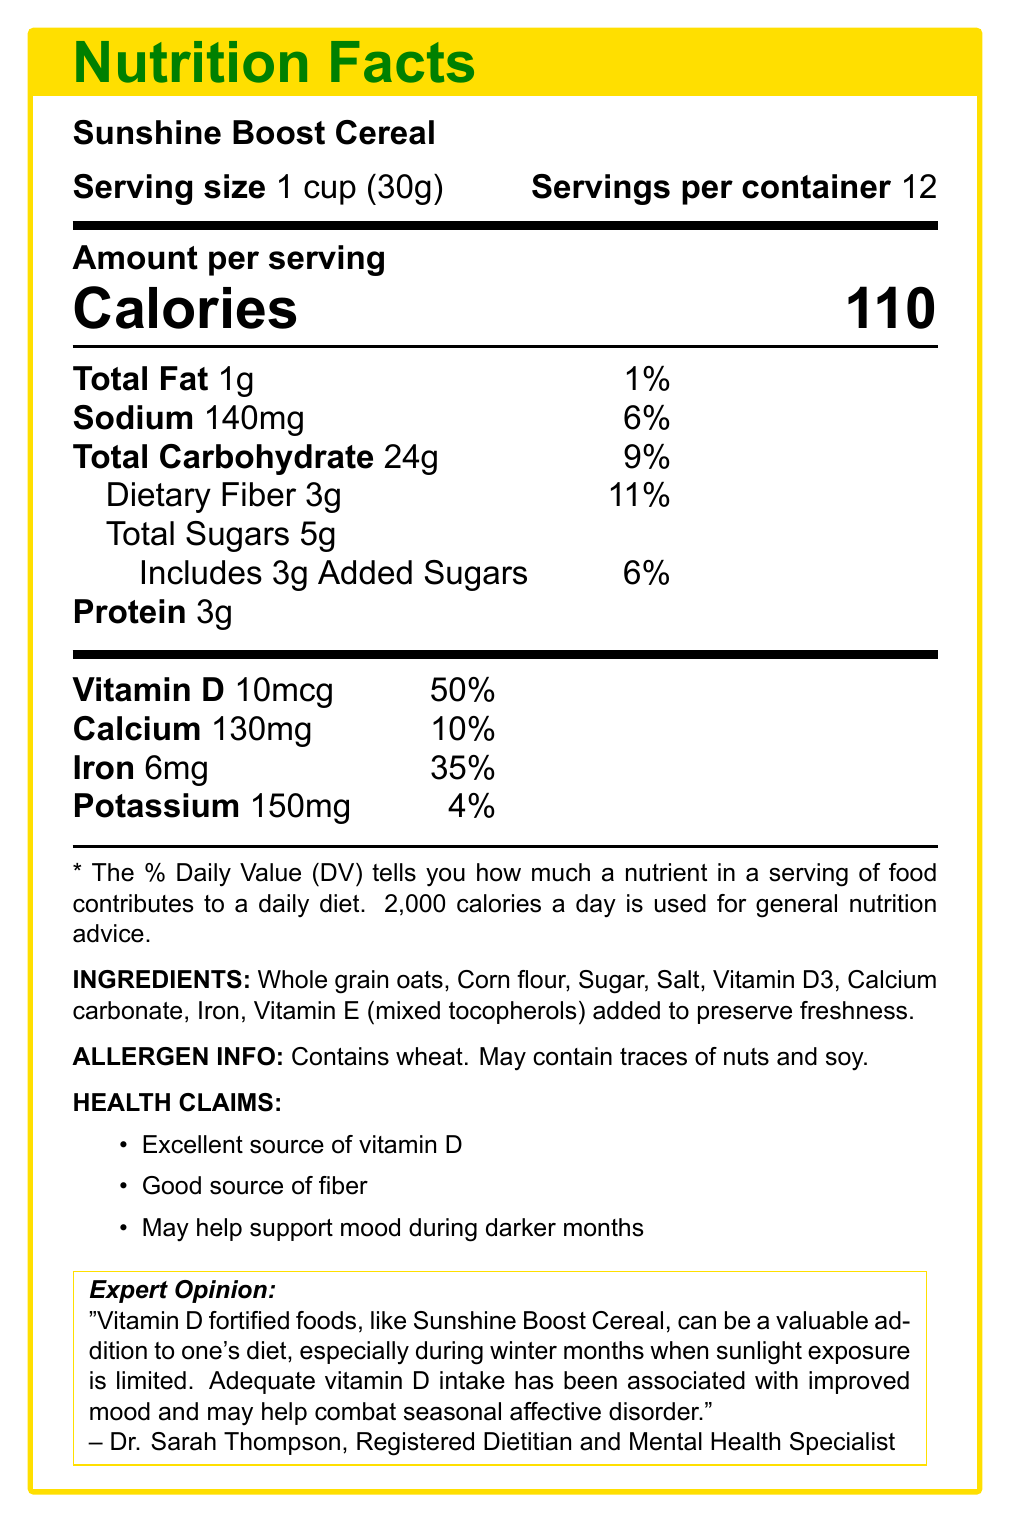what is the serving size of Sunshine Boost Cereal? The serving size is stated directly in the document as "1 cup (30g)."
Answer: 1 cup (30g) how many calories are in one serving of this cereal? The document specifies that each serving size contains 110 calories.
Answer: 110 calories how much vitamin D does one serving of Sunshine Boost Cereal provide? The amount of vitamin D per serving is listed as 10mcg.
Answer: 10mcg what percent of the daily value for vitamin D does one serving of this cereal provide? The document states that one serving provides 50% of the daily value.
Answer: 50% which nutrient has the highest percentage of the daily value in one serving of this cereal? The document shows that vitamin D has the highest daily value percentage at 50%.
Answer: Vitamin D what ingredient is used to add vitamin D to the cereal? Under the ingredients list, Vitamin D3 is mentioned as the ingredient for vitamin D fortification.
Answer: Vitamin D3 what is the expert opinion about vitamin D-fortified foods? This is directly quoted from Dr. Sarah Thompson, a Registered Dietitian and Mental Health Specialist.
Answer: "Vitamin D fortified foods, like Sunshine Boost Cereal, can be a valuable addition to one's diet, especially during winter months when sunlight exposure is limited. Adequate vitamin D intake has been associated with improved mood and may help combat seasonal affective disorder." what health claims does Sunshine Boost Cereal have? (Select all that apply) A. Excellent source of protein B. Good source of fiber C. May help support mood during darker months The health claims listed are: Excellent source of vitamin D, Good source of fiber, and May help support mood during darker months.
Answer: B and C how many servings are there per container? (numerical) A. 6 B. 8 C. 10 D. 12 The document specifies that there are 12 servings per container.
Answer: D is this cereal a good source of potassium? The document states that potassium only contributes 4% of the daily value, which does not qualify it as a "good source" based on dietary guidelines.
Answer: No describe the main purpose of the Sunshine Boost Cereal document. The document offers a comprehensive view of the nutritional benefits and potential mental health advantages of consuming Sunshine Boost Cereal, highlighting its role as a fortified food product.
Answer: The document provides nutritional information, ingredient details, allergen information, health claims, and expert opinion about Sunshine Boost Cereal. It emphasizes the cereal as a good source of vitamin D, which can help improve mood during darker months due to its role in combating seasonal affective disorder. how many grams of total sugars are found in one serving of Sunshine Boost Cereal? The document lists the total sugars content per serving as 5g.
Answer: 5g what study is mentioned in the document to support the claims about vitamin D and depressive symptoms? The document references a 2020 study published in the Journal of Affective Disorders which found that vitamin D supplementation positively affected depressive symptoms.
Answer: A 2020 study published in the Journal of Affective Disorders what percentage of the daily value of dietary fiber does one serving of Sunshine Boost Cereal provide? The document states that one serving provides 11% of the daily value for dietary fiber.
Answer: 11% what are some consumer tips for maximizing the benefits of Sunshine Boost Cereal? These tips are provided in the document under the consumer tips section.
Answer: "Pair this cereal with vitamin D-fortified milk for an extra boost," "Enjoy as part of a balanced breakfast that includes protein and healthy fats," and "Combine with outdoor morning exercise for synergistic mood-boosting effects." what is not listed among the ingredients of Sunshine Boost Cereal? A. Whole grain oats B. Corn flour C. Flax seeds The ingredient list includes whole grain oats, corn flour, sugar, salt, Vitamin D3, calcium carbonate, iron, and Vitamin E, but does not mention flax seeds.
Answer: C can it be determined what other vitamins and minerals, aside from those explicitly mentioned, are in the Sunshine Boost Cereal? The document does not provide information on vitamins and minerals other than vitamin D, calcium, iron, and potassium.
Answer: Cannot be determined 